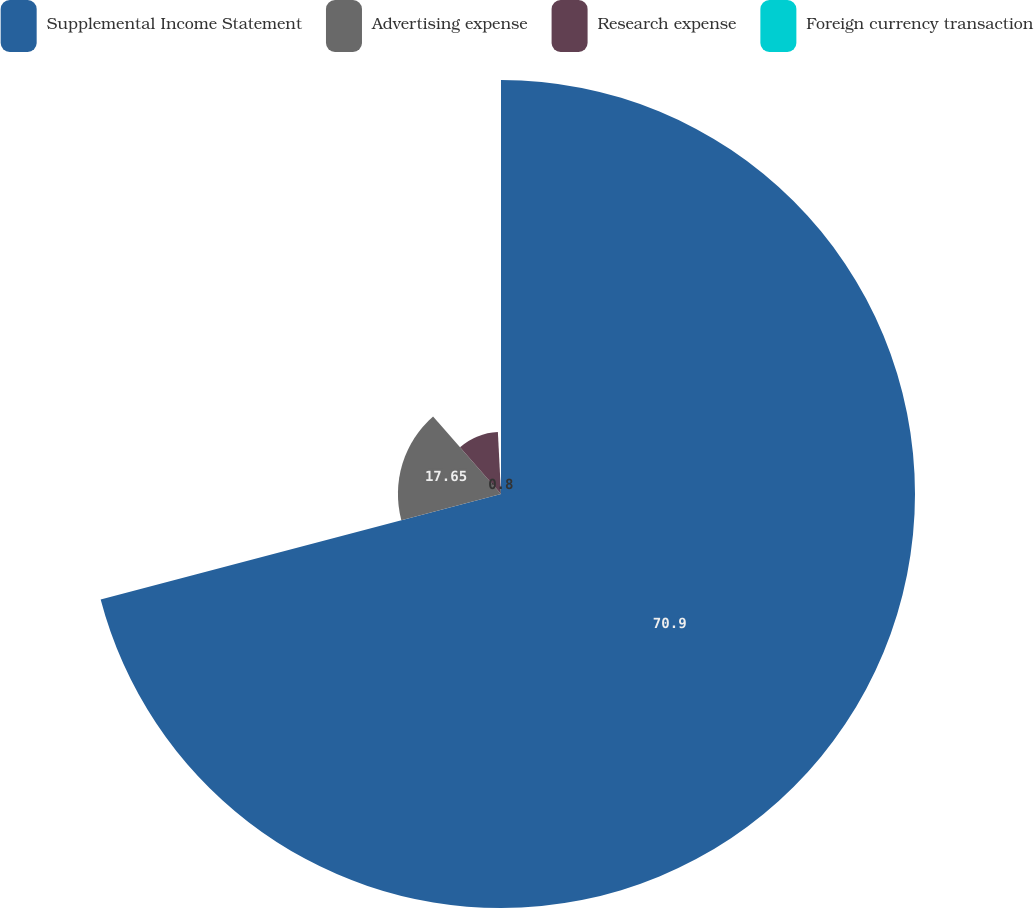Convert chart to OTSL. <chart><loc_0><loc_0><loc_500><loc_500><pie_chart><fcel>Supplemental Income Statement<fcel>Advertising expense<fcel>Research expense<fcel>Foreign currency transaction<nl><fcel>70.9%<fcel>17.65%<fcel>10.65%<fcel>0.8%<nl></chart> 